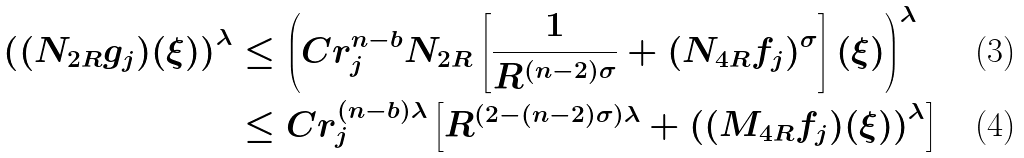<formula> <loc_0><loc_0><loc_500><loc_500>\left ( ( N _ { 2 R } g _ { j } ) ( \xi ) \right ) ^ { \lambda } & \leq \left ( C r ^ { n - b } _ { j } N _ { 2 R } \left [ \frac { 1 } { R ^ { ( n - 2 ) \sigma } } + ( N _ { 4 R } f _ { j } ) ^ { \sigma } \right ] ( \xi ) \right ) ^ { \lambda } \\ & \leq C r ^ { ( n - b ) \lambda } _ { j } \left [ R ^ { ( 2 - ( n - 2 ) \sigma ) \lambda } + \left ( ( M _ { 4 R } f _ { j } ) ( \xi ) \right ) ^ { \lambda } \right ]</formula> 